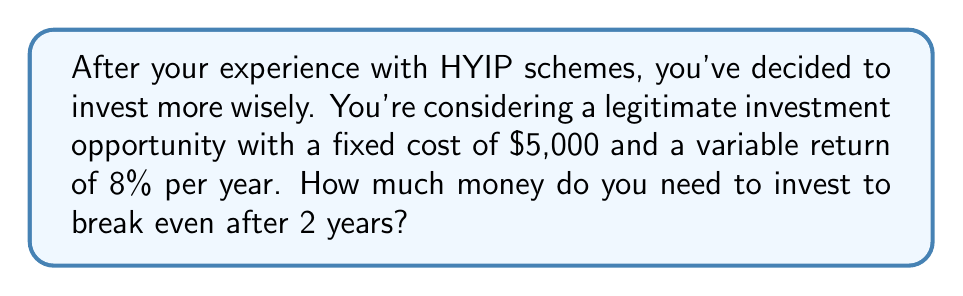Provide a solution to this math problem. Let's approach this step-by-step:

1) Let $x$ be the amount of money invested.

2) The break-even point is where the total return equals the initial investment plus the fixed cost. We can express this as an equation:

   $x + \text{Total Return} = x + \text{Fixed Cost}$

3) The total return over 2 years is:
   $8\% \times x \times 2 \text{ years} = 0.16x$

4) Now we can set up our equation:

   $x + 0.16x = x + 5000$

5) Simplify the left side:

   $1.16x = x + 5000$

6) Subtract $x$ from both sides:

   $0.16x = 5000$

7) Divide both sides by 0.16:

   $x = \frac{5000}{0.16} = 31,250$

Therefore, you need to invest $31,250 to break even after 2 years.
Answer: $31,250 